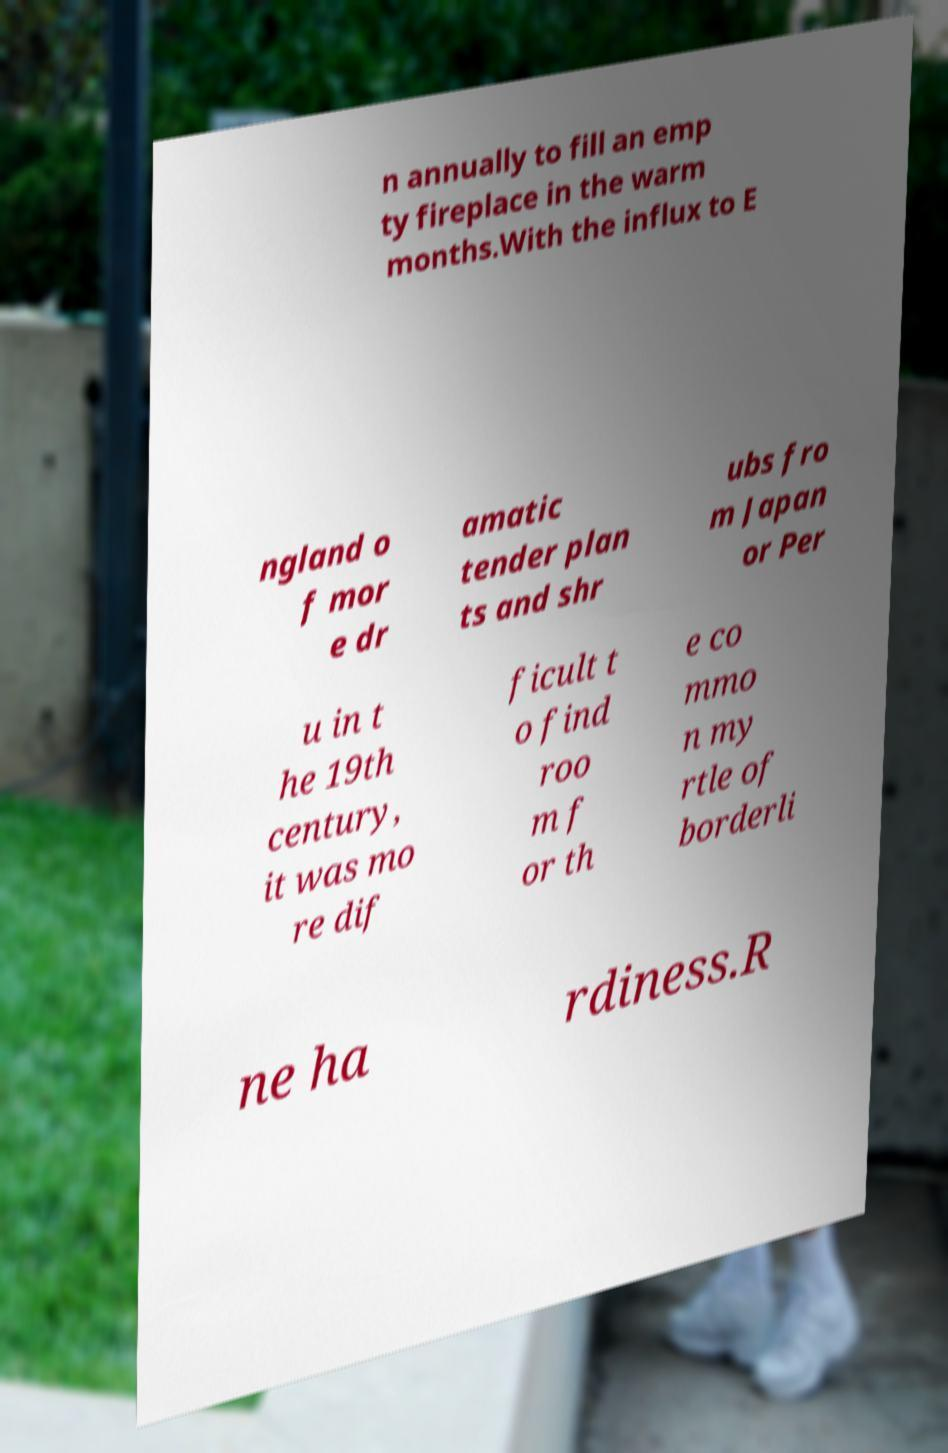Could you assist in decoding the text presented in this image and type it out clearly? n annually to fill an emp ty fireplace in the warm months.With the influx to E ngland o f mor e dr amatic tender plan ts and shr ubs fro m Japan or Per u in t he 19th century, it was mo re dif ficult t o find roo m f or th e co mmo n my rtle of borderli ne ha rdiness.R 